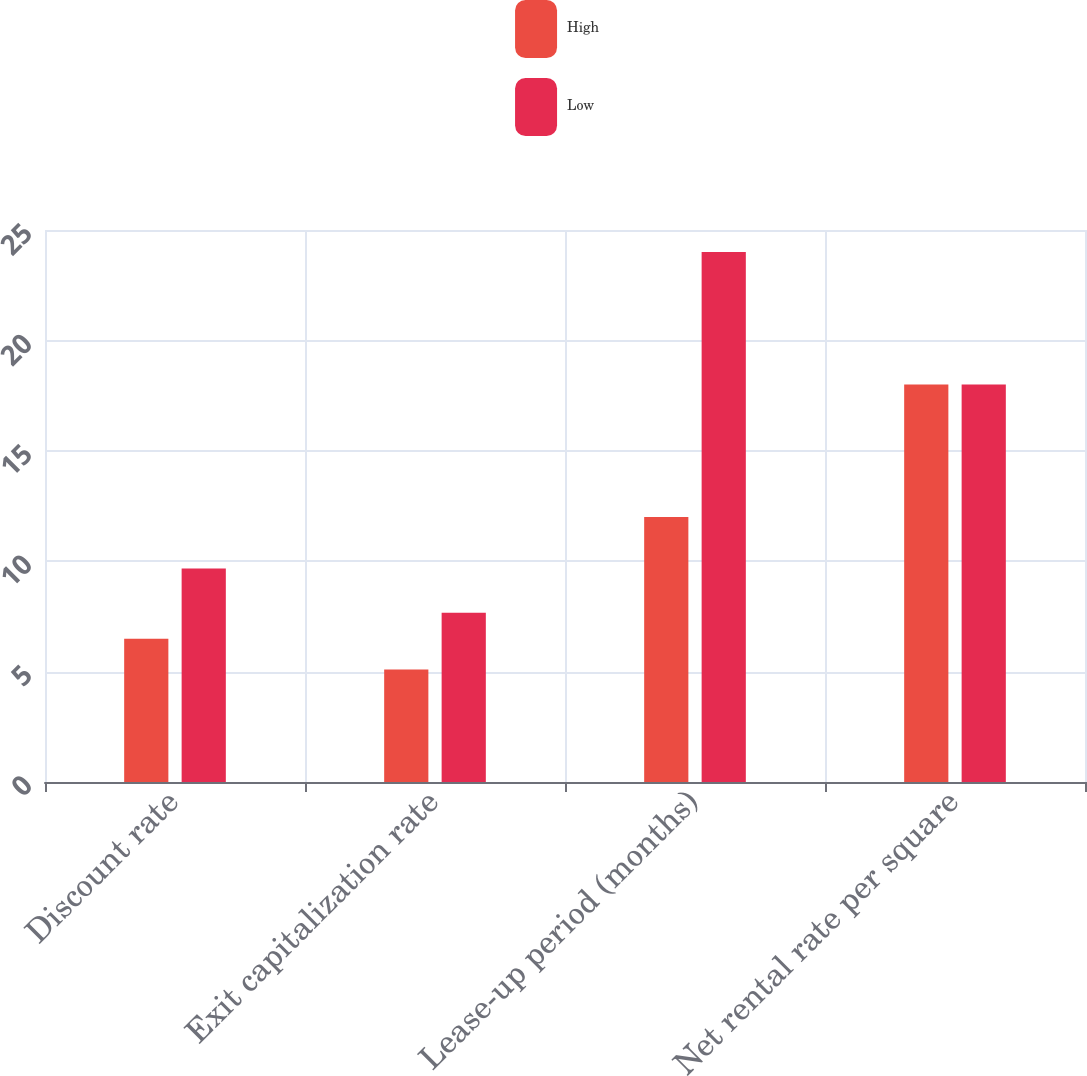<chart> <loc_0><loc_0><loc_500><loc_500><stacked_bar_chart><ecel><fcel>Discount rate<fcel>Exit capitalization rate<fcel>Lease-up period (months)<fcel>Net rental rate per square<nl><fcel>High<fcel>6.49<fcel>5.09<fcel>12<fcel>18<nl><fcel>Low<fcel>9.67<fcel>7.67<fcel>24<fcel>18<nl></chart> 